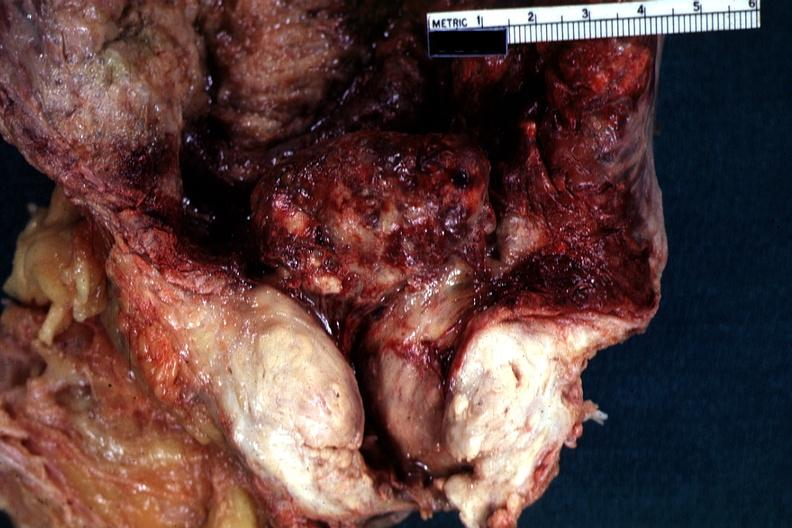does this image show close-up view of large median bar type lesion with severe cystitis?
Answer the question using a single word or phrase. Yes 